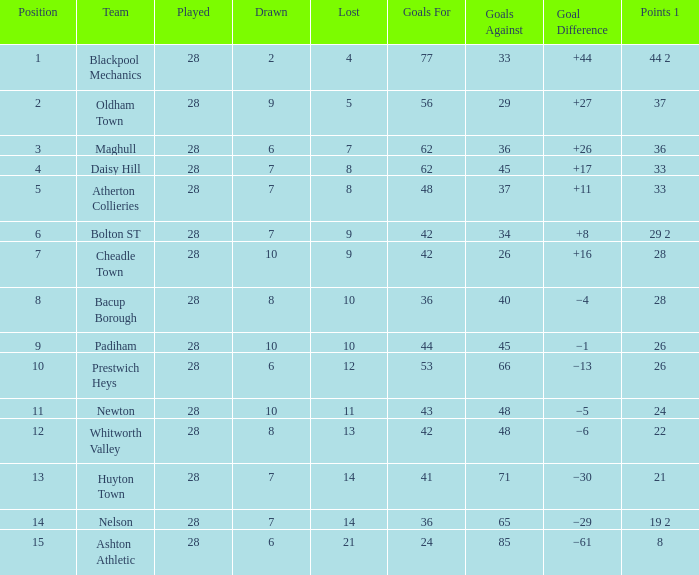What is the lowest drawn for entries with a lost of 13? 8.0. Can you give me this table as a dict? {'header': ['Position', 'Team', 'Played', 'Drawn', 'Lost', 'Goals For', 'Goals Against', 'Goal Difference', 'Points 1'], 'rows': [['1', 'Blackpool Mechanics', '28', '2', '4', '77', '33', '+44', '44 2'], ['2', 'Oldham Town', '28', '9', '5', '56', '29', '+27', '37'], ['3', 'Maghull', '28', '6', '7', '62', '36', '+26', '36'], ['4', 'Daisy Hill', '28', '7', '8', '62', '45', '+17', '33'], ['5', 'Atherton Collieries', '28', '7', '8', '48', '37', '+11', '33'], ['6', 'Bolton ST', '28', '7', '9', '42', '34', '+8', '29 2'], ['7', 'Cheadle Town', '28', '10', '9', '42', '26', '+16', '28'], ['8', 'Bacup Borough', '28', '8', '10', '36', '40', '−4', '28'], ['9', 'Padiham', '28', '10', '10', '44', '45', '−1', '26'], ['10', 'Prestwich Heys', '28', '6', '12', '53', '66', '−13', '26'], ['11', 'Newton', '28', '10', '11', '43', '48', '−5', '24'], ['12', 'Whitworth Valley', '28', '8', '13', '42', '48', '−6', '22'], ['13', 'Huyton Town', '28', '7', '14', '41', '71', '−30', '21'], ['14', 'Nelson', '28', '7', '14', '36', '65', '−29', '19 2'], ['15', 'Ashton Athletic', '28', '6', '21', '24', '85', '−61', '8']]} 